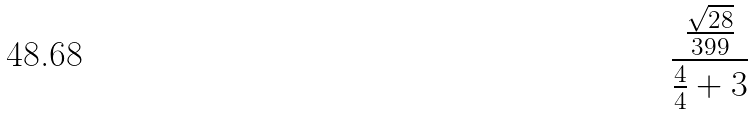<formula> <loc_0><loc_0><loc_500><loc_500>\frac { \frac { \sqrt { 2 8 } } { 3 9 9 } } { \frac { 4 } { 4 } + 3 }</formula> 